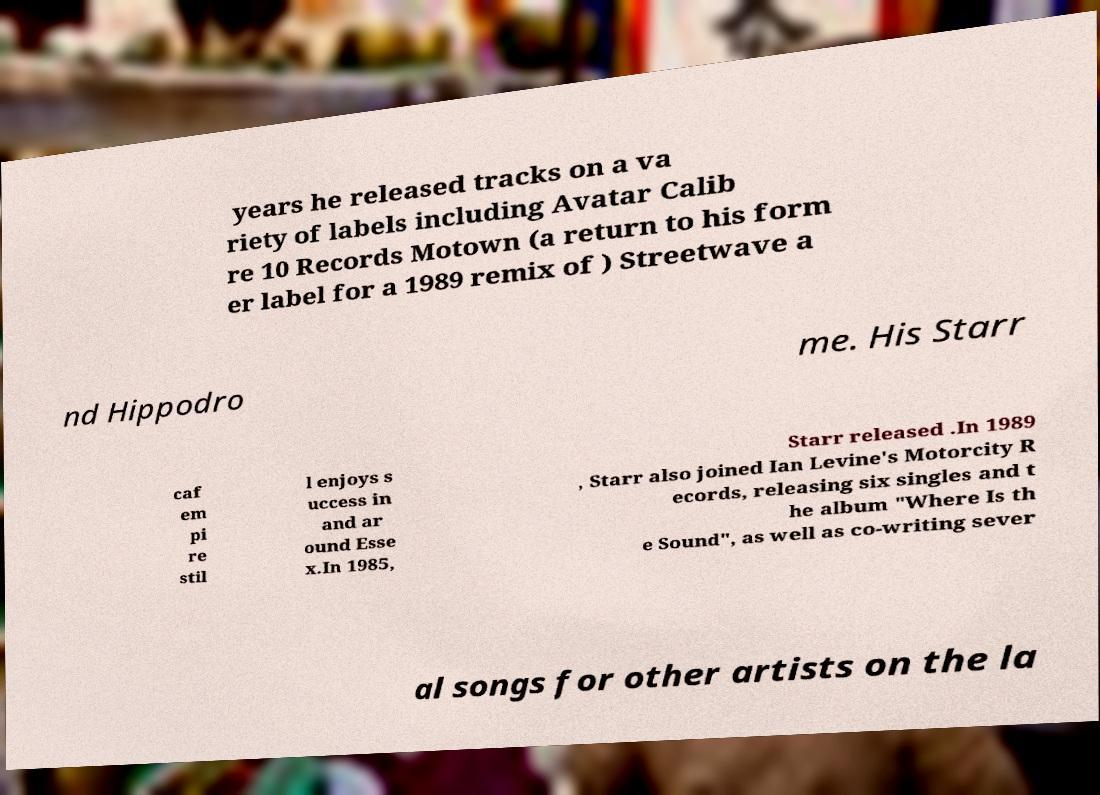I need the written content from this picture converted into text. Can you do that? years he released tracks on a va riety of labels including Avatar Calib re 10 Records Motown (a return to his form er label for a 1989 remix of ) Streetwave a nd Hippodro me. His Starr caf em pi re stil l enjoys s uccess in and ar ound Esse x.In 1985, Starr released .In 1989 , Starr also joined Ian Levine's Motorcity R ecords, releasing six singles and t he album "Where Is th e Sound", as well as co-writing sever al songs for other artists on the la 